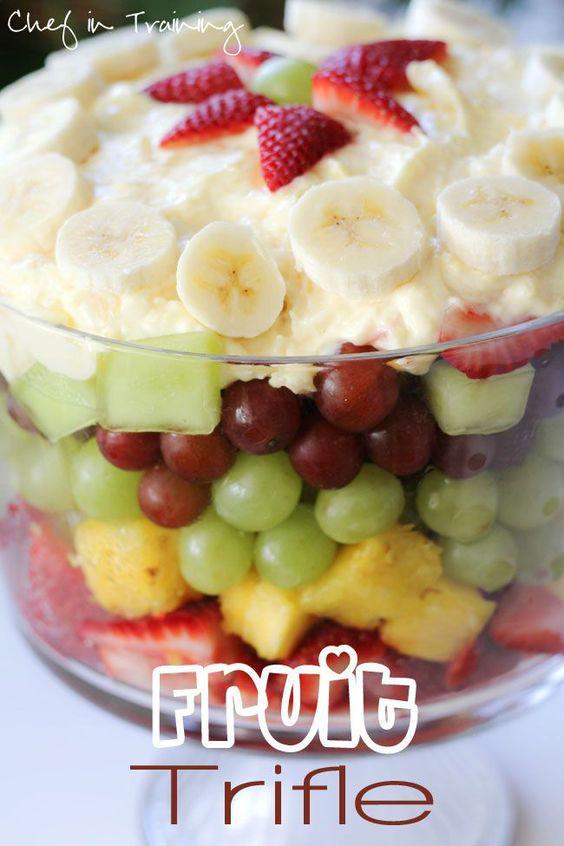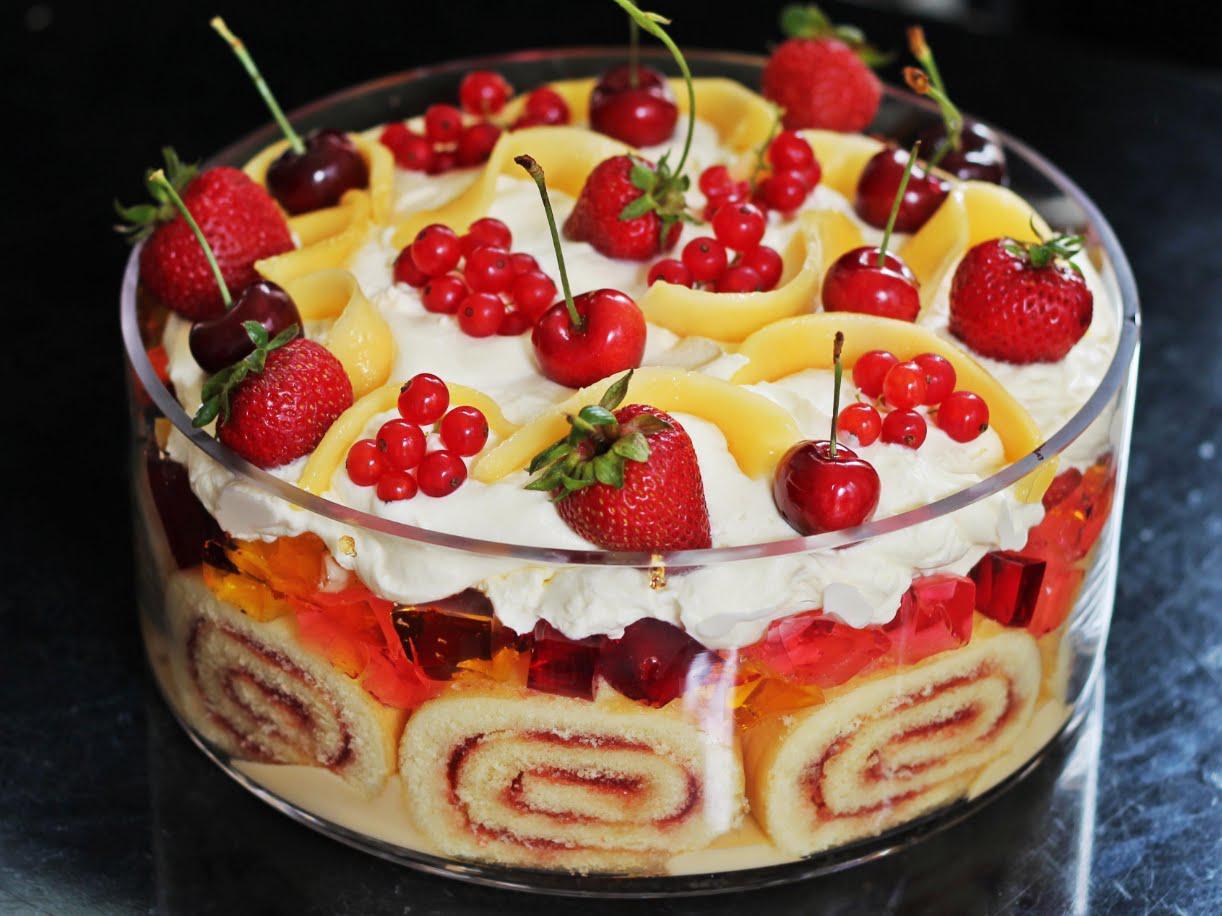The first image is the image on the left, the second image is the image on the right. Considering the images on both sides, is "There is exactly one container in the image on the right." valid? Answer yes or no. Yes. 